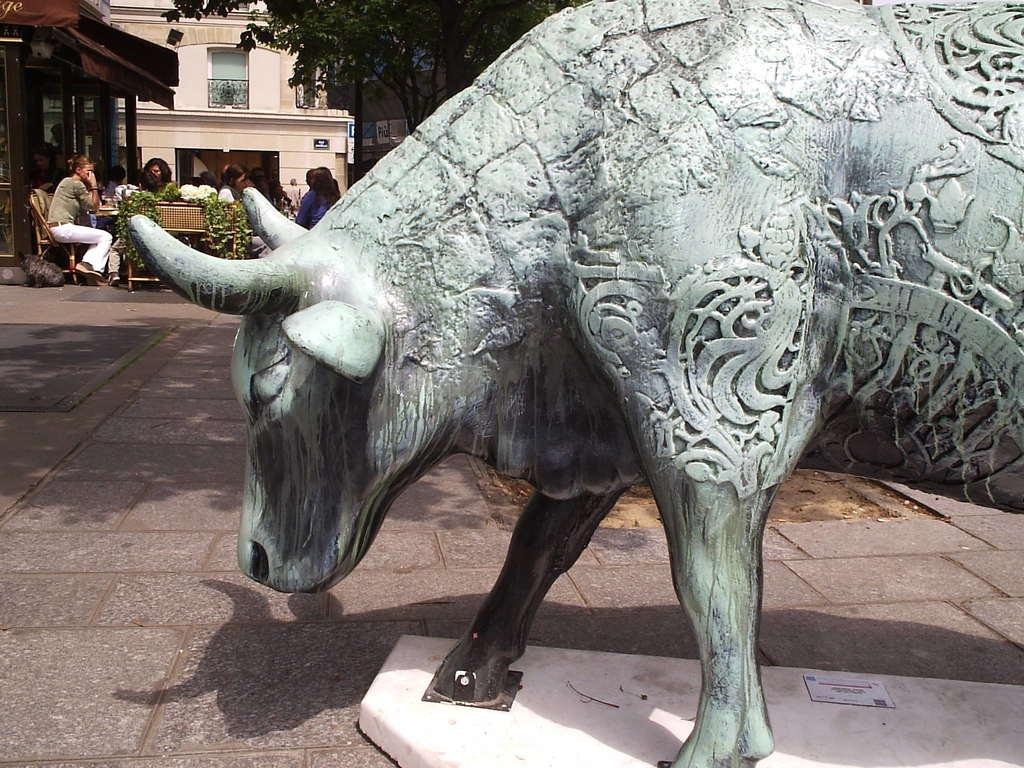What is the main subject of the sculpture in the image? There is a sculpture of a bull in the image. What are the people in the image doing? The people in the image are sitting on chairs around a table. What type of structures can be seen in the image? There are buildings in the image. What type of vegetation is present in the image? There are trees and plants in the image. What type of leather is used to make the statement in the image? There is no leather or statement present in the image. 